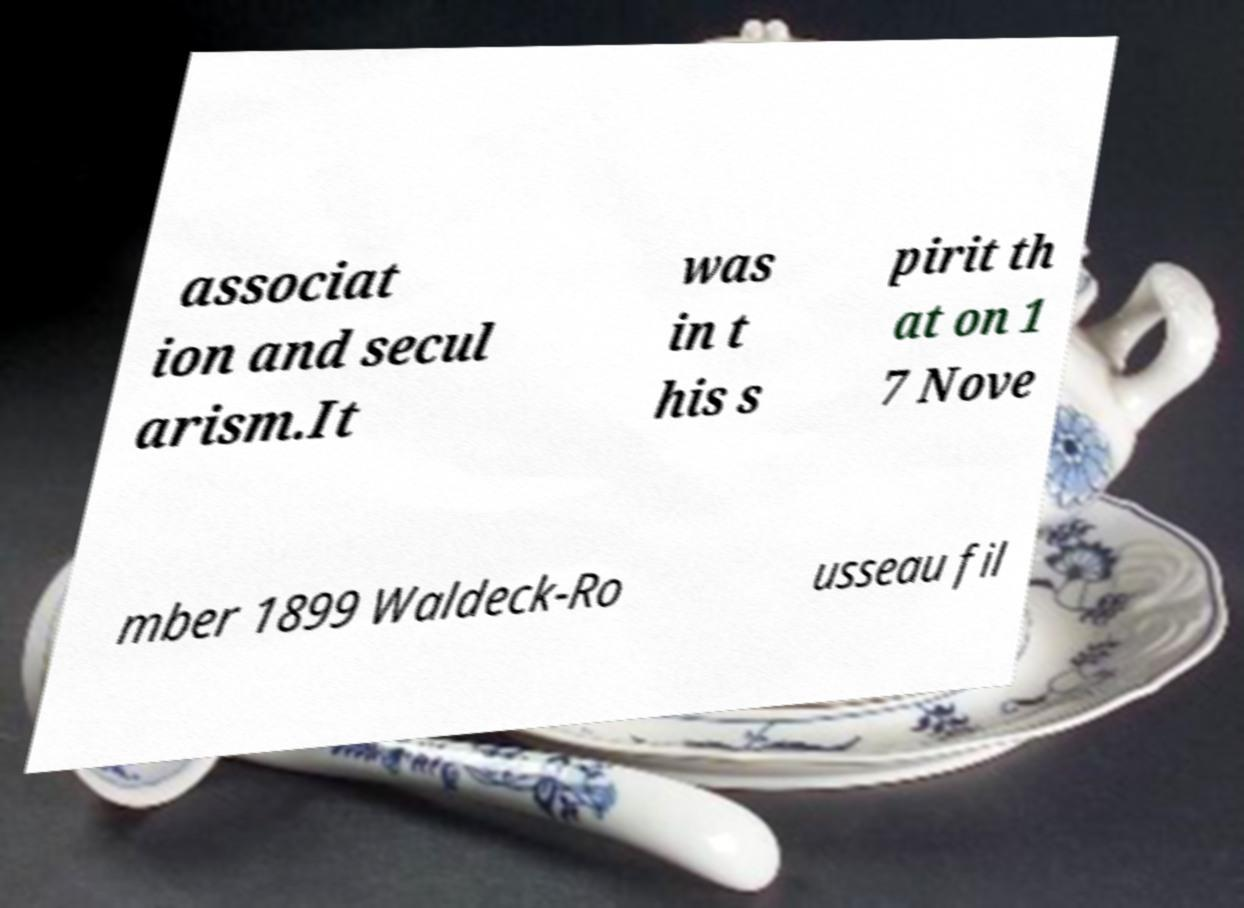Can you read and provide the text displayed in the image?This photo seems to have some interesting text. Can you extract and type it out for me? associat ion and secul arism.It was in t his s pirit th at on 1 7 Nove mber 1899 Waldeck-Ro usseau fil 